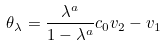Convert formula to latex. <formula><loc_0><loc_0><loc_500><loc_500>\theta _ { \lambda } = \frac { \lambda ^ { a } } { 1 - \lambda ^ { a } } c _ { 0 } v _ { 2 } - v _ { 1 }</formula> 